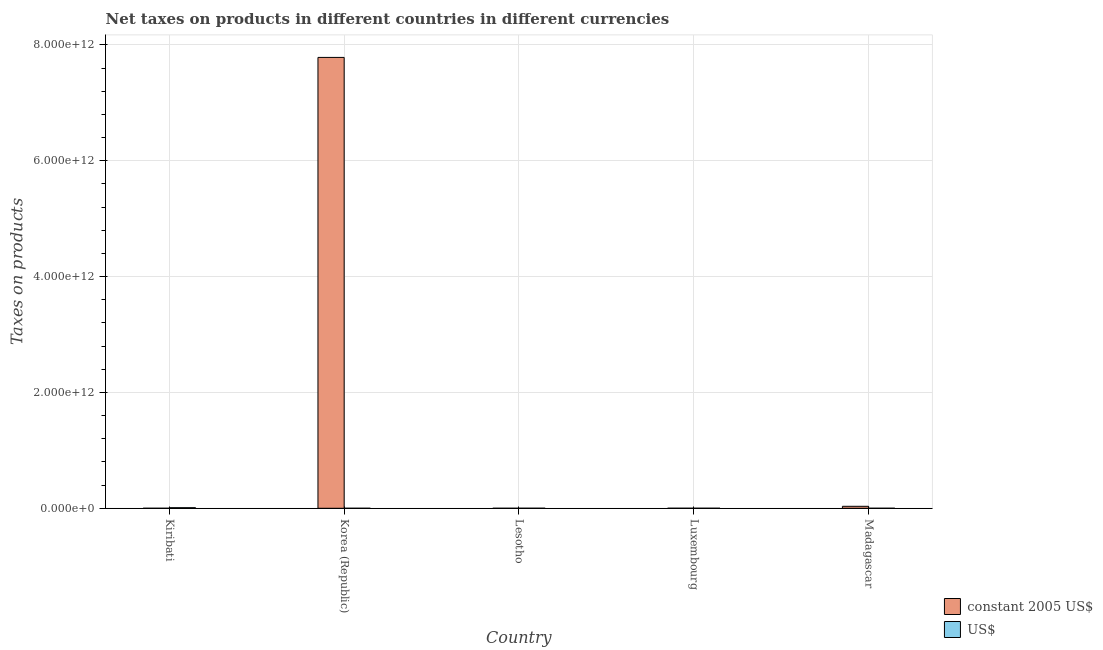How many different coloured bars are there?
Your answer should be compact. 2. Are the number of bars on each tick of the X-axis equal?
Offer a very short reply. Yes. How many bars are there on the 1st tick from the right?
Provide a succinct answer. 2. What is the label of the 2nd group of bars from the left?
Provide a succinct answer. Korea (Republic). In how many cases, is the number of bars for a given country not equal to the number of legend labels?
Provide a succinct answer. 0. What is the net taxes in us$ in Korea (Republic)?
Provide a short and direct response. 2.30e+07. Across all countries, what is the maximum net taxes in constant 2005 us$?
Give a very brief answer. 7.78e+12. Across all countries, what is the minimum net taxes in us$?
Give a very brief answer. 2.30e+07. In which country was the net taxes in constant 2005 us$ maximum?
Give a very brief answer. Korea (Republic). What is the total net taxes in us$ in the graph?
Offer a terse response. 1.09e+1. What is the difference between the net taxes in constant 2005 us$ in Kiribati and that in Madagascar?
Make the answer very short. -3.40e+1. What is the difference between the net taxes in constant 2005 us$ in Madagascar and the net taxes in us$ in Luxembourg?
Provide a short and direct response. 3.36e+1. What is the average net taxes in us$ per country?
Offer a very short reply. 2.19e+09. What is the difference between the net taxes in us$ and net taxes in constant 2005 us$ in Madagascar?
Make the answer very short. -3.38e+1. What is the ratio of the net taxes in constant 2005 us$ in Kiribati to that in Madagascar?
Provide a short and direct response. 2.9037265059517852e-5. Is the net taxes in us$ in Luxembourg less than that in Madagascar?
Your answer should be compact. No. What is the difference between the highest and the second highest net taxes in constant 2005 us$?
Offer a terse response. 7.75e+12. What is the difference between the highest and the lowest net taxes in constant 2005 us$?
Your answer should be compact. 7.78e+12. In how many countries, is the net taxes in us$ greater than the average net taxes in us$ taken over all countries?
Your answer should be compact. 1. Is the sum of the net taxes in us$ in Kiribati and Madagascar greater than the maximum net taxes in constant 2005 us$ across all countries?
Your response must be concise. No. What does the 2nd bar from the left in Madagascar represents?
Give a very brief answer. US$. What does the 2nd bar from the right in Lesotho represents?
Offer a very short reply. Constant 2005 us$. How many bars are there?
Offer a terse response. 10. How many countries are there in the graph?
Your answer should be compact. 5. What is the difference between two consecutive major ticks on the Y-axis?
Keep it short and to the point. 2.00e+12. Does the graph contain grids?
Your response must be concise. Yes. Where does the legend appear in the graph?
Keep it short and to the point. Bottom right. What is the title of the graph?
Your answer should be very brief. Net taxes on products in different countries in different currencies. What is the label or title of the X-axis?
Keep it short and to the point. Country. What is the label or title of the Y-axis?
Make the answer very short. Taxes on products. What is the Taxes on products in constant 2005 US$ in Kiribati?
Provide a short and direct response. 9.86e+05. What is the Taxes on products in US$ in Kiribati?
Keep it short and to the point. 1.00e+1. What is the Taxes on products of constant 2005 US$ in Korea (Republic)?
Provide a succinct answer. 7.78e+12. What is the Taxes on products in US$ in Korea (Republic)?
Offer a very short reply. 2.30e+07. What is the Taxes on products in constant 2005 US$ in Lesotho?
Offer a terse response. 2.57e+07. What is the Taxes on products in US$ in Lesotho?
Your response must be concise. 3.59e+08. What is the Taxes on products in constant 2005 US$ in Luxembourg?
Your answer should be very brief. 4.55e+08. What is the Taxes on products in US$ in Luxembourg?
Your response must be concise. 3.94e+08. What is the Taxes on products in constant 2005 US$ in Madagascar?
Offer a terse response. 3.40e+1. What is the Taxes on products in US$ in Madagascar?
Provide a short and direct response. 1.19e+08. Across all countries, what is the maximum Taxes on products in constant 2005 US$?
Your response must be concise. 7.78e+12. Across all countries, what is the maximum Taxes on products in US$?
Provide a short and direct response. 1.00e+1. Across all countries, what is the minimum Taxes on products in constant 2005 US$?
Your response must be concise. 9.86e+05. Across all countries, what is the minimum Taxes on products of US$?
Your response must be concise. 2.30e+07. What is the total Taxes on products in constant 2005 US$ in the graph?
Give a very brief answer. 7.82e+12. What is the total Taxes on products in US$ in the graph?
Offer a very short reply. 1.09e+1. What is the difference between the Taxes on products of constant 2005 US$ in Kiribati and that in Korea (Republic)?
Offer a terse response. -7.78e+12. What is the difference between the Taxes on products in US$ in Kiribati and that in Korea (Republic)?
Your answer should be compact. 1.00e+1. What is the difference between the Taxes on products in constant 2005 US$ in Kiribati and that in Lesotho?
Your answer should be very brief. -2.47e+07. What is the difference between the Taxes on products in US$ in Kiribati and that in Lesotho?
Provide a succinct answer. 9.68e+09. What is the difference between the Taxes on products in constant 2005 US$ in Kiribati and that in Luxembourg?
Your response must be concise. -4.54e+08. What is the difference between the Taxes on products of US$ in Kiribati and that in Luxembourg?
Offer a terse response. 9.64e+09. What is the difference between the Taxes on products in constant 2005 US$ in Kiribati and that in Madagascar?
Your answer should be compact. -3.40e+1. What is the difference between the Taxes on products in US$ in Kiribati and that in Madagascar?
Provide a short and direct response. 9.92e+09. What is the difference between the Taxes on products in constant 2005 US$ in Korea (Republic) and that in Lesotho?
Provide a short and direct response. 7.78e+12. What is the difference between the Taxes on products in US$ in Korea (Republic) and that in Lesotho?
Make the answer very short. -3.36e+08. What is the difference between the Taxes on products in constant 2005 US$ in Korea (Republic) and that in Luxembourg?
Ensure brevity in your answer.  7.78e+12. What is the difference between the Taxes on products in US$ in Korea (Republic) and that in Luxembourg?
Offer a very short reply. -3.71e+08. What is the difference between the Taxes on products of constant 2005 US$ in Korea (Republic) and that in Madagascar?
Keep it short and to the point. 7.75e+12. What is the difference between the Taxes on products in US$ in Korea (Republic) and that in Madagascar?
Your answer should be very brief. -9.58e+07. What is the difference between the Taxes on products in constant 2005 US$ in Lesotho and that in Luxembourg?
Your answer should be very brief. -4.29e+08. What is the difference between the Taxes on products in US$ in Lesotho and that in Luxembourg?
Offer a terse response. -3.56e+07. What is the difference between the Taxes on products in constant 2005 US$ in Lesotho and that in Madagascar?
Give a very brief answer. -3.39e+1. What is the difference between the Taxes on products in US$ in Lesotho and that in Madagascar?
Offer a terse response. 2.40e+08. What is the difference between the Taxes on products in constant 2005 US$ in Luxembourg and that in Madagascar?
Your answer should be compact. -3.35e+1. What is the difference between the Taxes on products of US$ in Luxembourg and that in Madagascar?
Make the answer very short. 2.76e+08. What is the difference between the Taxes on products in constant 2005 US$ in Kiribati and the Taxes on products in US$ in Korea (Republic)?
Provide a short and direct response. -2.20e+07. What is the difference between the Taxes on products in constant 2005 US$ in Kiribati and the Taxes on products in US$ in Lesotho?
Your answer should be compact. -3.58e+08. What is the difference between the Taxes on products in constant 2005 US$ in Kiribati and the Taxes on products in US$ in Luxembourg?
Offer a very short reply. -3.93e+08. What is the difference between the Taxes on products of constant 2005 US$ in Kiribati and the Taxes on products of US$ in Madagascar?
Your answer should be very brief. -1.18e+08. What is the difference between the Taxes on products of constant 2005 US$ in Korea (Republic) and the Taxes on products of US$ in Lesotho?
Make the answer very short. 7.78e+12. What is the difference between the Taxes on products of constant 2005 US$ in Korea (Republic) and the Taxes on products of US$ in Luxembourg?
Keep it short and to the point. 7.78e+12. What is the difference between the Taxes on products of constant 2005 US$ in Korea (Republic) and the Taxes on products of US$ in Madagascar?
Provide a succinct answer. 7.78e+12. What is the difference between the Taxes on products in constant 2005 US$ in Lesotho and the Taxes on products in US$ in Luxembourg?
Keep it short and to the point. -3.69e+08. What is the difference between the Taxes on products of constant 2005 US$ in Lesotho and the Taxes on products of US$ in Madagascar?
Give a very brief answer. -9.32e+07. What is the difference between the Taxes on products in constant 2005 US$ in Luxembourg and the Taxes on products in US$ in Madagascar?
Make the answer very short. 3.36e+08. What is the average Taxes on products of constant 2005 US$ per country?
Offer a very short reply. 1.56e+12. What is the average Taxes on products in US$ per country?
Make the answer very short. 2.19e+09. What is the difference between the Taxes on products in constant 2005 US$ and Taxes on products in US$ in Kiribati?
Offer a very short reply. -1.00e+1. What is the difference between the Taxes on products in constant 2005 US$ and Taxes on products in US$ in Korea (Republic)?
Provide a short and direct response. 7.78e+12. What is the difference between the Taxes on products of constant 2005 US$ and Taxes on products of US$ in Lesotho?
Ensure brevity in your answer.  -3.33e+08. What is the difference between the Taxes on products in constant 2005 US$ and Taxes on products in US$ in Luxembourg?
Provide a succinct answer. 6.03e+07. What is the difference between the Taxes on products in constant 2005 US$ and Taxes on products in US$ in Madagascar?
Offer a very short reply. 3.38e+1. What is the ratio of the Taxes on products of constant 2005 US$ in Kiribati to that in Korea (Republic)?
Offer a terse response. 0. What is the ratio of the Taxes on products in US$ in Kiribati to that in Korea (Republic)?
Offer a very short reply. 435.64. What is the ratio of the Taxes on products in constant 2005 US$ in Kiribati to that in Lesotho?
Your response must be concise. 0.04. What is the ratio of the Taxes on products in US$ in Kiribati to that in Lesotho?
Give a very brief answer. 27.97. What is the ratio of the Taxes on products in constant 2005 US$ in Kiribati to that in Luxembourg?
Your response must be concise. 0. What is the ratio of the Taxes on products of US$ in Kiribati to that in Luxembourg?
Offer a terse response. 25.44. What is the ratio of the Taxes on products of US$ in Kiribati to that in Madagascar?
Your answer should be very brief. 84.44. What is the ratio of the Taxes on products in constant 2005 US$ in Korea (Republic) to that in Lesotho?
Provide a short and direct response. 3.03e+05. What is the ratio of the Taxes on products in US$ in Korea (Republic) to that in Lesotho?
Your response must be concise. 0.06. What is the ratio of the Taxes on products in constant 2005 US$ in Korea (Republic) to that in Luxembourg?
Offer a very short reply. 1.71e+04. What is the ratio of the Taxes on products of US$ in Korea (Republic) to that in Luxembourg?
Provide a short and direct response. 0.06. What is the ratio of the Taxes on products in constant 2005 US$ in Korea (Republic) to that in Madagascar?
Offer a terse response. 229.23. What is the ratio of the Taxes on products of US$ in Korea (Republic) to that in Madagascar?
Give a very brief answer. 0.19. What is the ratio of the Taxes on products in constant 2005 US$ in Lesotho to that in Luxembourg?
Keep it short and to the point. 0.06. What is the ratio of the Taxes on products of US$ in Lesotho to that in Luxembourg?
Give a very brief answer. 0.91. What is the ratio of the Taxes on products in constant 2005 US$ in Lesotho to that in Madagascar?
Your response must be concise. 0. What is the ratio of the Taxes on products in US$ in Lesotho to that in Madagascar?
Your answer should be compact. 3.02. What is the ratio of the Taxes on products in constant 2005 US$ in Luxembourg to that in Madagascar?
Keep it short and to the point. 0.01. What is the ratio of the Taxes on products of US$ in Luxembourg to that in Madagascar?
Ensure brevity in your answer.  3.32. What is the difference between the highest and the second highest Taxes on products of constant 2005 US$?
Your answer should be very brief. 7.75e+12. What is the difference between the highest and the second highest Taxes on products in US$?
Your answer should be very brief. 9.64e+09. What is the difference between the highest and the lowest Taxes on products of constant 2005 US$?
Ensure brevity in your answer.  7.78e+12. What is the difference between the highest and the lowest Taxes on products in US$?
Ensure brevity in your answer.  1.00e+1. 